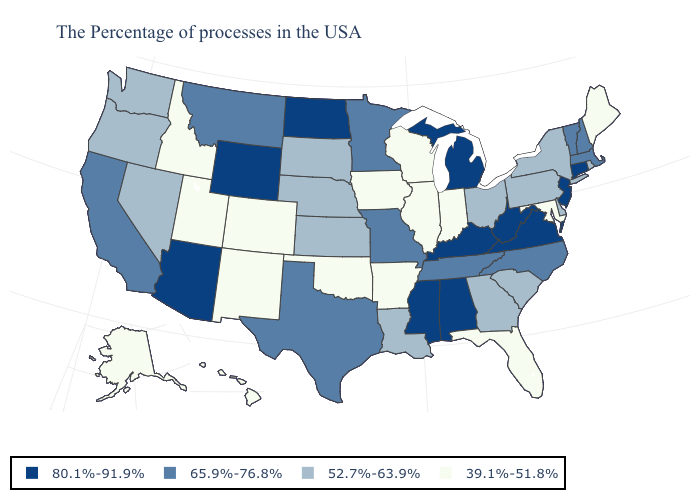Does Vermont have the same value as New York?
Write a very short answer. No. What is the highest value in the West ?
Quick response, please. 80.1%-91.9%. Name the states that have a value in the range 39.1%-51.8%?
Write a very short answer. Maine, Maryland, Florida, Indiana, Wisconsin, Illinois, Arkansas, Iowa, Oklahoma, Colorado, New Mexico, Utah, Idaho, Alaska, Hawaii. What is the value of West Virginia?
Concise answer only. 80.1%-91.9%. Does Washington have the lowest value in the USA?
Concise answer only. No. Does Maine have the lowest value in the Northeast?
Short answer required. Yes. Does Virginia have the highest value in the South?
Quick response, please. Yes. Name the states that have a value in the range 80.1%-91.9%?
Short answer required. Connecticut, New Jersey, Virginia, West Virginia, Michigan, Kentucky, Alabama, Mississippi, North Dakota, Wyoming, Arizona. Does Kansas have a lower value than Maryland?
Quick response, please. No. What is the value of North Dakota?
Keep it brief. 80.1%-91.9%. What is the value of Hawaii?
Concise answer only. 39.1%-51.8%. Which states have the lowest value in the USA?
Short answer required. Maine, Maryland, Florida, Indiana, Wisconsin, Illinois, Arkansas, Iowa, Oklahoma, Colorado, New Mexico, Utah, Idaho, Alaska, Hawaii. Does the map have missing data?
Keep it brief. No. Among the states that border South Dakota , which have the highest value?
Give a very brief answer. North Dakota, Wyoming. Name the states that have a value in the range 52.7%-63.9%?
Keep it brief. Rhode Island, New York, Delaware, Pennsylvania, South Carolina, Ohio, Georgia, Louisiana, Kansas, Nebraska, South Dakota, Nevada, Washington, Oregon. 